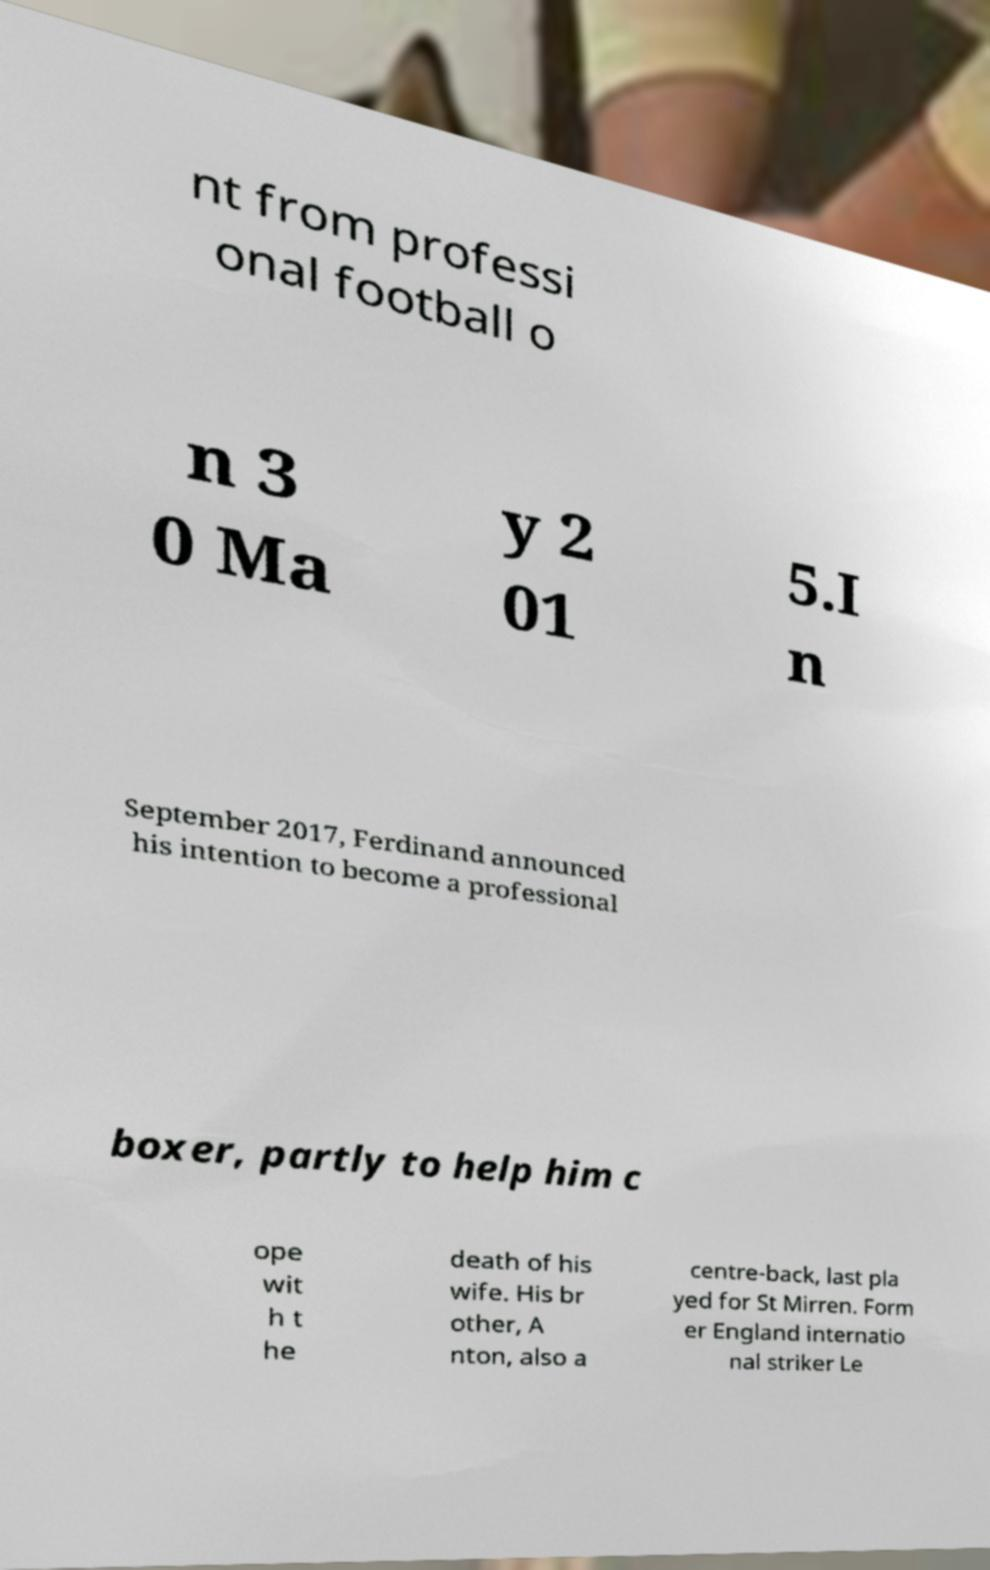For documentation purposes, I need the text within this image transcribed. Could you provide that? nt from professi onal football o n 3 0 Ma y 2 01 5.I n September 2017, Ferdinand announced his intention to become a professional boxer, partly to help him c ope wit h t he death of his wife. His br other, A nton, also a centre-back, last pla yed for St Mirren. Form er England internatio nal striker Le 